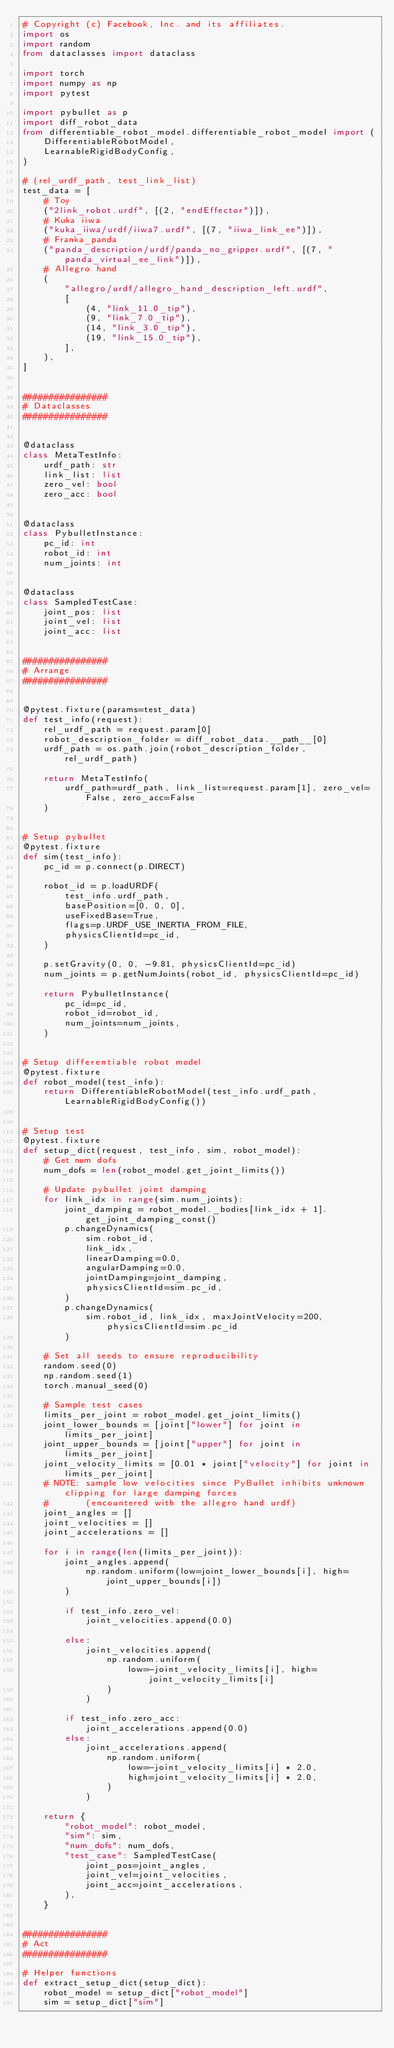Convert code to text. <code><loc_0><loc_0><loc_500><loc_500><_Python_># Copyright (c) Facebook, Inc. and its affiliates.
import os
import random
from dataclasses import dataclass

import torch
import numpy as np
import pytest

import pybullet as p
import diff_robot_data
from differentiable_robot_model.differentiable_robot_model import (
    DifferentiableRobotModel,
    LearnableRigidBodyConfig,
)

# (rel_urdf_path, test_link_list)
test_data = [
    # Toy
    ("2link_robot.urdf", [(2, "endEffector")]),
    # Kuka iiwa
    ("kuka_iiwa/urdf/iiwa7.urdf", [(7, "iiwa_link_ee")]),
    # Franka_panda
    ("panda_description/urdf/panda_no_gripper.urdf", [(7, "panda_virtual_ee_link")]),
    # Allegro hand
    (
        "allegro/urdf/allegro_hand_description_left.urdf",
        [
            (4, "link_11.0_tip"),
            (9, "link_7.0_tip"),
            (14, "link_3.0_tip"),
            (19, "link_15.0_tip"),
        ],
    ),
]


################
# Dataclasses
################


@dataclass
class MetaTestInfo:
    urdf_path: str
    link_list: list
    zero_vel: bool
    zero_acc: bool


@dataclass
class PybulletInstance:
    pc_id: int
    robot_id: int
    num_joints: int


@dataclass
class SampledTestCase:
    joint_pos: list
    joint_vel: list
    joint_acc: list


################
# Arrange
################


@pytest.fixture(params=test_data)
def test_info(request):
    rel_urdf_path = request.param[0]
    robot_description_folder = diff_robot_data.__path__[0]
    urdf_path = os.path.join(robot_description_folder, rel_urdf_path)

    return MetaTestInfo(
        urdf_path=urdf_path, link_list=request.param[1], zero_vel=False, zero_acc=False
    )


# Setup pybullet
@pytest.fixture
def sim(test_info):
    pc_id = p.connect(p.DIRECT)

    robot_id = p.loadURDF(
        test_info.urdf_path,
        basePosition=[0, 0, 0],
        useFixedBase=True,
        flags=p.URDF_USE_INERTIA_FROM_FILE,
        physicsClientId=pc_id,
    )

    p.setGravity(0, 0, -9.81, physicsClientId=pc_id)
    num_joints = p.getNumJoints(robot_id, physicsClientId=pc_id)

    return PybulletInstance(
        pc_id=pc_id,
        robot_id=robot_id,
        num_joints=num_joints,
    )


# Setup differentiable robot model
@pytest.fixture
def robot_model(test_info):
    return DifferentiableRobotModel(test_info.urdf_path, LearnableRigidBodyConfig())


# Setup test
@pytest.fixture
def setup_dict(request, test_info, sim, robot_model):
    # Get num dofs
    num_dofs = len(robot_model.get_joint_limits())

    # Update pybullet joint damping
    for link_idx in range(sim.num_joints):
        joint_damping = robot_model._bodies[link_idx + 1].get_joint_damping_const()
        p.changeDynamics(
            sim.robot_id,
            link_idx,
            linearDamping=0.0,
            angularDamping=0.0,
            jointDamping=joint_damping,
            physicsClientId=sim.pc_id,
        )
        p.changeDynamics(
            sim.robot_id, link_idx, maxJointVelocity=200, physicsClientId=sim.pc_id
        )

    # Set all seeds to ensure reproducibility
    random.seed(0)
    np.random.seed(1)
    torch.manual_seed(0)

    # Sample test cases
    limits_per_joint = robot_model.get_joint_limits()
    joint_lower_bounds = [joint["lower"] for joint in limits_per_joint]
    joint_upper_bounds = [joint["upper"] for joint in limits_per_joint]
    joint_velocity_limits = [0.01 * joint["velocity"] for joint in limits_per_joint]
    # NOTE: sample low velocities since PyBullet inhibits unknown clipping for large damping forces
    #       (encountered with the allegro hand urdf)
    joint_angles = []
    joint_velocities = []
    joint_accelerations = []

    for i in range(len(limits_per_joint)):
        joint_angles.append(
            np.random.uniform(low=joint_lower_bounds[i], high=joint_upper_bounds[i])
        )

        if test_info.zero_vel:
            joint_velocities.append(0.0)

        else:
            joint_velocities.append(
                np.random.uniform(
                    low=-joint_velocity_limits[i], high=joint_velocity_limits[i]
                )
            )

        if test_info.zero_acc:
            joint_accelerations.append(0.0)
        else:
            joint_accelerations.append(
                np.random.uniform(
                    low=-joint_velocity_limits[i] * 2.0,
                    high=joint_velocity_limits[i] * 2.0,
                )
            )

    return {
        "robot_model": robot_model,
        "sim": sim,
        "num_dofs": num_dofs,
        "test_case": SampledTestCase(
            joint_pos=joint_angles,
            joint_vel=joint_velocities,
            joint_acc=joint_accelerations,
        ),
    }


################
# Act
################

# Helper functions
def extract_setup_dict(setup_dict):
    robot_model = setup_dict["robot_model"]
    sim = setup_dict["sim"]</code> 